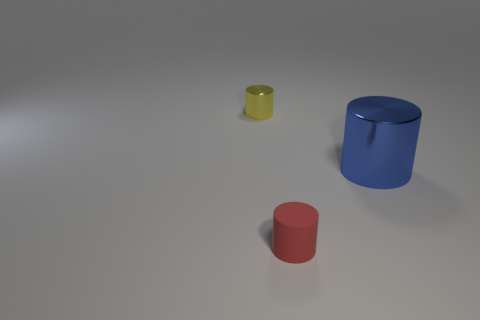There is a tiny cylinder right of the metal cylinder left of the rubber thing; what is its material?
Keep it short and to the point. Rubber. What is the size of the rubber thing that is the same shape as the tiny yellow metal thing?
Ensure brevity in your answer.  Small. What color is the thing that is both behind the small red rubber cylinder and in front of the yellow metal thing?
Provide a succinct answer. Blue. There is a blue cylinder that is in front of the yellow metal object; does it have the same size as the small red cylinder?
Offer a terse response. No. Do the blue cylinder and the small cylinder behind the big object have the same material?
Provide a short and direct response. Yes. What number of green objects are either cylinders or matte cubes?
Give a very brief answer. 0. Are any rubber cylinders visible?
Your response must be concise. Yes. There is a small cylinder in front of the shiny object that is on the left side of the blue metal object; are there any yellow metal things on the left side of it?
Keep it short and to the point. Yes. Is there any other thing that is the same size as the blue shiny object?
Your answer should be compact. No. Do the big object and the tiny thing that is to the right of the yellow cylinder have the same shape?
Offer a very short reply. Yes. 